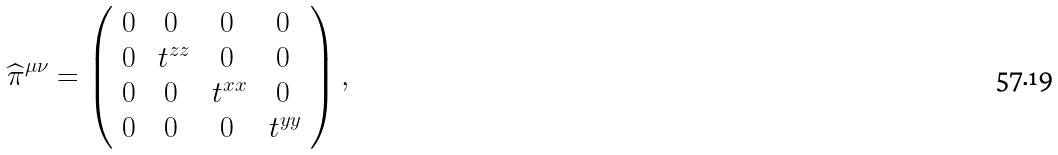Convert formula to latex. <formula><loc_0><loc_0><loc_500><loc_500>\widehat { \pi } ^ { \mu \nu } = \left ( \begin{array} { c c c c } 0 & 0 & 0 & 0 \\ 0 & \ t ^ { z z } & 0 & 0 \\ 0 & 0 & \ t ^ { x x } & 0 \\ 0 & 0 & 0 & \ t ^ { y y } \end{array} \right ) ,</formula> 